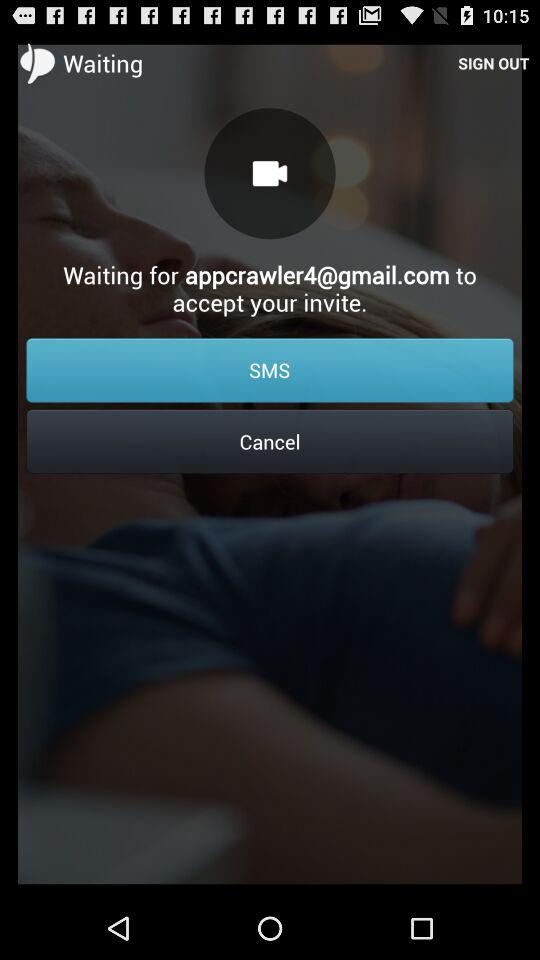What is the email address given? The email address is appcrawler4@gmail.com. 